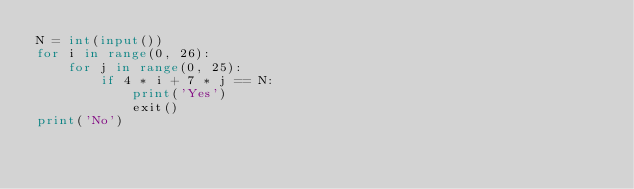Convert code to text. <code><loc_0><loc_0><loc_500><loc_500><_Python_>N = int(input())
for i in range(0, 26):
    for j in range(0, 25):
        if 4 * i + 7 * j == N:
            print('Yes')
            exit()
print('No')</code> 